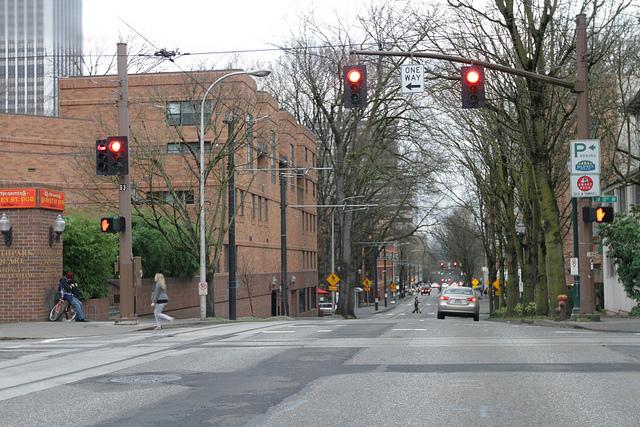Do the trees have leaves?
Short answer required. No. Is this winter?
Be succinct. No. Is this pedestrian properly crossing the street?
Write a very short answer. Yes. What is the traffic light?
Be succinct. Red. Will you be turning left on a one-way street?
Quick response, please. Yes. 